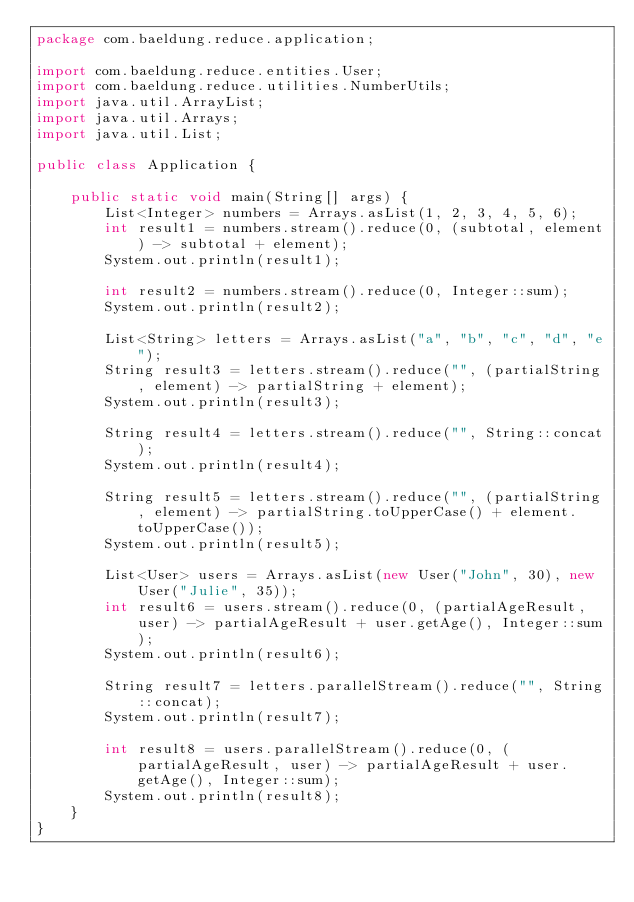<code> <loc_0><loc_0><loc_500><loc_500><_Java_>package com.baeldung.reduce.application;

import com.baeldung.reduce.entities.User;
import com.baeldung.reduce.utilities.NumberUtils;
import java.util.ArrayList;
import java.util.Arrays;
import java.util.List;

public class Application {

    public static void main(String[] args) {
        List<Integer> numbers = Arrays.asList(1, 2, 3, 4, 5, 6);
        int result1 = numbers.stream().reduce(0, (subtotal, element) -> subtotal + element);
        System.out.println(result1);
        
        int result2 = numbers.stream().reduce(0, Integer::sum);
        System.out.println(result2);

        List<String> letters = Arrays.asList("a", "b", "c", "d", "e");
        String result3 = letters.stream().reduce("", (partialString, element) -> partialString + element);
        System.out.println(result3);
        
        String result4 = letters.stream().reduce("", String::concat);
        System.out.println(result4);

        String result5 = letters.stream().reduce("", (partialString, element) -> partialString.toUpperCase() + element.toUpperCase());
        System.out.println(result5);
        
        List<User> users = Arrays.asList(new User("John", 30), new User("Julie", 35));
        int result6 = users.stream().reduce(0, (partialAgeResult, user) -> partialAgeResult + user.getAge(), Integer::sum);
        System.out.println(result6);
        
        String result7 = letters.parallelStream().reduce("", String::concat);
        System.out.println(result7);
        
        int result8 = users.parallelStream().reduce(0, (partialAgeResult, user) -> partialAgeResult + user.getAge(), Integer::sum);
        System.out.println(result8);
    }    
}
</code> 